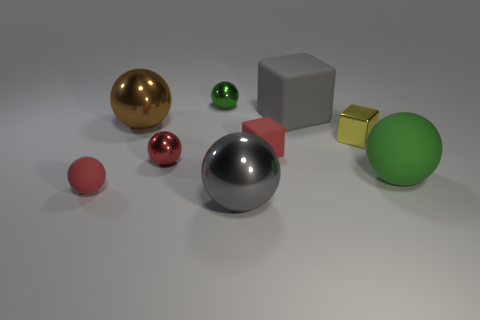What number of objects are either gray balls or objects to the right of the red matte block?
Offer a terse response. 4. There is a green object that is on the right side of the sphere in front of the tiny red rubber ball; what size is it?
Ensure brevity in your answer.  Large. Is the number of tiny green objects that are left of the big brown shiny sphere the same as the number of tiny yellow blocks to the left of the tiny yellow shiny cube?
Your answer should be compact. Yes. Are there any large spheres that are on the right side of the green ball behind the tiny yellow metallic cube?
Make the answer very short. Yes. The yellow object that is the same material as the tiny green thing is what shape?
Keep it short and to the point. Cube. Is there anything else of the same color as the small metallic block?
Keep it short and to the point. No. What material is the gray thing that is in front of the red matte thing behind the green matte ball?
Offer a terse response. Metal. Is there a yellow metal object of the same shape as the tiny green object?
Offer a terse response. No. What number of other objects are there of the same shape as the small yellow thing?
Offer a terse response. 2. There is a red thing that is to the left of the green metallic thing and on the right side of the red matte sphere; what shape is it?
Your answer should be compact. Sphere. 